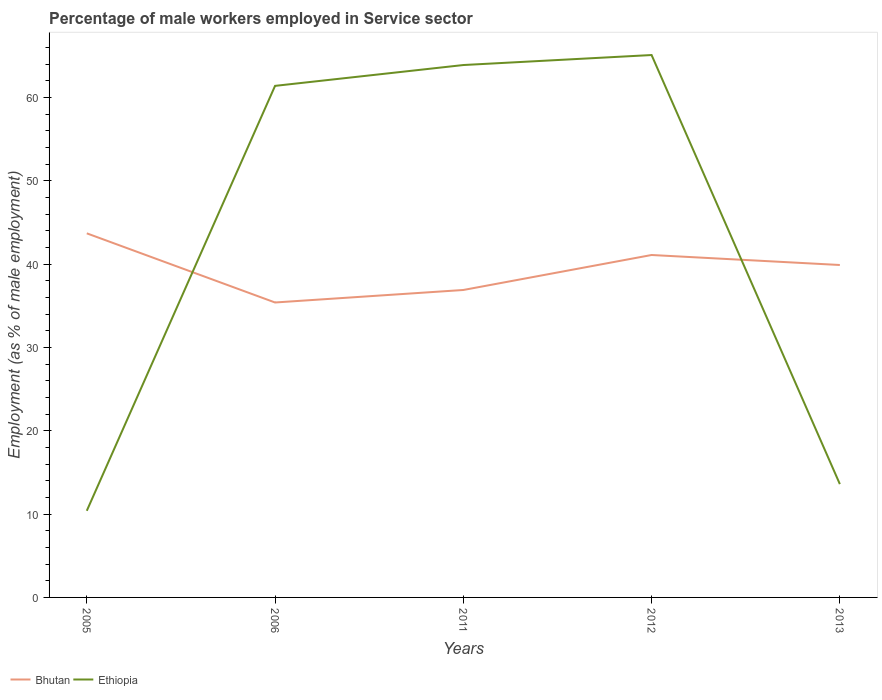Across all years, what is the maximum percentage of male workers employed in Service sector in Bhutan?
Give a very brief answer. 35.4. In which year was the percentage of male workers employed in Service sector in Ethiopia maximum?
Provide a short and direct response. 2005. What is the total percentage of male workers employed in Service sector in Bhutan in the graph?
Offer a very short reply. -4.2. What is the difference between the highest and the second highest percentage of male workers employed in Service sector in Bhutan?
Your response must be concise. 8.3. How many lines are there?
Make the answer very short. 2. How many years are there in the graph?
Your response must be concise. 5. What is the difference between two consecutive major ticks on the Y-axis?
Your answer should be very brief. 10. Does the graph contain any zero values?
Keep it short and to the point. No. Does the graph contain grids?
Offer a terse response. No. Where does the legend appear in the graph?
Make the answer very short. Bottom left. How many legend labels are there?
Offer a terse response. 2. What is the title of the graph?
Your answer should be compact. Percentage of male workers employed in Service sector. What is the label or title of the Y-axis?
Your answer should be compact. Employment (as % of male employment). What is the Employment (as % of male employment) of Bhutan in 2005?
Offer a very short reply. 43.7. What is the Employment (as % of male employment) in Ethiopia in 2005?
Provide a succinct answer. 10.4. What is the Employment (as % of male employment) in Bhutan in 2006?
Make the answer very short. 35.4. What is the Employment (as % of male employment) in Ethiopia in 2006?
Ensure brevity in your answer.  61.4. What is the Employment (as % of male employment) in Bhutan in 2011?
Offer a terse response. 36.9. What is the Employment (as % of male employment) of Ethiopia in 2011?
Provide a succinct answer. 63.9. What is the Employment (as % of male employment) of Bhutan in 2012?
Provide a short and direct response. 41.1. What is the Employment (as % of male employment) of Ethiopia in 2012?
Ensure brevity in your answer.  65.1. What is the Employment (as % of male employment) in Bhutan in 2013?
Ensure brevity in your answer.  39.9. What is the Employment (as % of male employment) in Ethiopia in 2013?
Ensure brevity in your answer.  13.6. Across all years, what is the maximum Employment (as % of male employment) of Bhutan?
Give a very brief answer. 43.7. Across all years, what is the maximum Employment (as % of male employment) in Ethiopia?
Offer a terse response. 65.1. Across all years, what is the minimum Employment (as % of male employment) of Bhutan?
Offer a very short reply. 35.4. Across all years, what is the minimum Employment (as % of male employment) in Ethiopia?
Offer a terse response. 10.4. What is the total Employment (as % of male employment) of Bhutan in the graph?
Offer a very short reply. 197. What is the total Employment (as % of male employment) of Ethiopia in the graph?
Your answer should be compact. 214.4. What is the difference between the Employment (as % of male employment) of Ethiopia in 2005 and that in 2006?
Your response must be concise. -51. What is the difference between the Employment (as % of male employment) of Bhutan in 2005 and that in 2011?
Provide a short and direct response. 6.8. What is the difference between the Employment (as % of male employment) of Ethiopia in 2005 and that in 2011?
Your answer should be compact. -53.5. What is the difference between the Employment (as % of male employment) of Bhutan in 2005 and that in 2012?
Provide a short and direct response. 2.6. What is the difference between the Employment (as % of male employment) in Ethiopia in 2005 and that in 2012?
Give a very brief answer. -54.7. What is the difference between the Employment (as % of male employment) in Ethiopia in 2005 and that in 2013?
Keep it short and to the point. -3.2. What is the difference between the Employment (as % of male employment) of Ethiopia in 2006 and that in 2011?
Provide a succinct answer. -2.5. What is the difference between the Employment (as % of male employment) in Ethiopia in 2006 and that in 2012?
Keep it short and to the point. -3.7. What is the difference between the Employment (as % of male employment) of Bhutan in 2006 and that in 2013?
Your answer should be compact. -4.5. What is the difference between the Employment (as % of male employment) of Ethiopia in 2006 and that in 2013?
Keep it short and to the point. 47.8. What is the difference between the Employment (as % of male employment) in Ethiopia in 2011 and that in 2012?
Make the answer very short. -1.2. What is the difference between the Employment (as % of male employment) in Ethiopia in 2011 and that in 2013?
Keep it short and to the point. 50.3. What is the difference between the Employment (as % of male employment) in Ethiopia in 2012 and that in 2013?
Provide a short and direct response. 51.5. What is the difference between the Employment (as % of male employment) in Bhutan in 2005 and the Employment (as % of male employment) in Ethiopia in 2006?
Ensure brevity in your answer.  -17.7. What is the difference between the Employment (as % of male employment) in Bhutan in 2005 and the Employment (as % of male employment) in Ethiopia in 2011?
Your answer should be very brief. -20.2. What is the difference between the Employment (as % of male employment) in Bhutan in 2005 and the Employment (as % of male employment) in Ethiopia in 2012?
Offer a very short reply. -21.4. What is the difference between the Employment (as % of male employment) in Bhutan in 2005 and the Employment (as % of male employment) in Ethiopia in 2013?
Provide a succinct answer. 30.1. What is the difference between the Employment (as % of male employment) of Bhutan in 2006 and the Employment (as % of male employment) of Ethiopia in 2011?
Your answer should be compact. -28.5. What is the difference between the Employment (as % of male employment) in Bhutan in 2006 and the Employment (as % of male employment) in Ethiopia in 2012?
Your answer should be very brief. -29.7. What is the difference between the Employment (as % of male employment) of Bhutan in 2006 and the Employment (as % of male employment) of Ethiopia in 2013?
Ensure brevity in your answer.  21.8. What is the difference between the Employment (as % of male employment) in Bhutan in 2011 and the Employment (as % of male employment) in Ethiopia in 2012?
Your response must be concise. -28.2. What is the difference between the Employment (as % of male employment) in Bhutan in 2011 and the Employment (as % of male employment) in Ethiopia in 2013?
Your response must be concise. 23.3. What is the average Employment (as % of male employment) of Bhutan per year?
Offer a terse response. 39.4. What is the average Employment (as % of male employment) of Ethiopia per year?
Your answer should be compact. 42.88. In the year 2005, what is the difference between the Employment (as % of male employment) of Bhutan and Employment (as % of male employment) of Ethiopia?
Make the answer very short. 33.3. In the year 2006, what is the difference between the Employment (as % of male employment) in Bhutan and Employment (as % of male employment) in Ethiopia?
Your answer should be compact. -26. In the year 2011, what is the difference between the Employment (as % of male employment) of Bhutan and Employment (as % of male employment) of Ethiopia?
Your response must be concise. -27. In the year 2013, what is the difference between the Employment (as % of male employment) in Bhutan and Employment (as % of male employment) in Ethiopia?
Your response must be concise. 26.3. What is the ratio of the Employment (as % of male employment) in Bhutan in 2005 to that in 2006?
Give a very brief answer. 1.23. What is the ratio of the Employment (as % of male employment) in Ethiopia in 2005 to that in 2006?
Your response must be concise. 0.17. What is the ratio of the Employment (as % of male employment) in Bhutan in 2005 to that in 2011?
Your answer should be very brief. 1.18. What is the ratio of the Employment (as % of male employment) in Ethiopia in 2005 to that in 2011?
Your response must be concise. 0.16. What is the ratio of the Employment (as % of male employment) of Bhutan in 2005 to that in 2012?
Keep it short and to the point. 1.06. What is the ratio of the Employment (as % of male employment) of Ethiopia in 2005 to that in 2012?
Your response must be concise. 0.16. What is the ratio of the Employment (as % of male employment) in Bhutan in 2005 to that in 2013?
Provide a short and direct response. 1.1. What is the ratio of the Employment (as % of male employment) of Ethiopia in 2005 to that in 2013?
Provide a succinct answer. 0.76. What is the ratio of the Employment (as % of male employment) in Bhutan in 2006 to that in 2011?
Your answer should be compact. 0.96. What is the ratio of the Employment (as % of male employment) in Ethiopia in 2006 to that in 2011?
Offer a terse response. 0.96. What is the ratio of the Employment (as % of male employment) in Bhutan in 2006 to that in 2012?
Offer a terse response. 0.86. What is the ratio of the Employment (as % of male employment) of Ethiopia in 2006 to that in 2012?
Offer a very short reply. 0.94. What is the ratio of the Employment (as % of male employment) in Bhutan in 2006 to that in 2013?
Your answer should be compact. 0.89. What is the ratio of the Employment (as % of male employment) in Ethiopia in 2006 to that in 2013?
Keep it short and to the point. 4.51. What is the ratio of the Employment (as % of male employment) in Bhutan in 2011 to that in 2012?
Make the answer very short. 0.9. What is the ratio of the Employment (as % of male employment) of Ethiopia in 2011 to that in 2012?
Your response must be concise. 0.98. What is the ratio of the Employment (as % of male employment) in Bhutan in 2011 to that in 2013?
Your answer should be compact. 0.92. What is the ratio of the Employment (as % of male employment) in Ethiopia in 2011 to that in 2013?
Your response must be concise. 4.7. What is the ratio of the Employment (as % of male employment) in Bhutan in 2012 to that in 2013?
Give a very brief answer. 1.03. What is the ratio of the Employment (as % of male employment) in Ethiopia in 2012 to that in 2013?
Keep it short and to the point. 4.79. What is the difference between the highest and the second highest Employment (as % of male employment) of Bhutan?
Provide a succinct answer. 2.6. What is the difference between the highest and the second highest Employment (as % of male employment) of Ethiopia?
Your response must be concise. 1.2. What is the difference between the highest and the lowest Employment (as % of male employment) in Bhutan?
Make the answer very short. 8.3. What is the difference between the highest and the lowest Employment (as % of male employment) in Ethiopia?
Your answer should be compact. 54.7. 